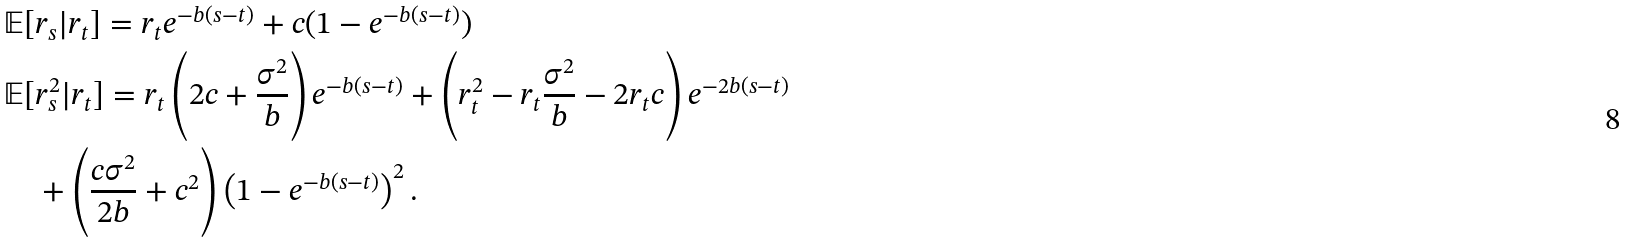Convert formula to latex. <formula><loc_0><loc_0><loc_500><loc_500>& \mathbb { E } [ r _ { s } | r _ { t } ] = r _ { t } e ^ { - b ( s - t ) } + c ( 1 - e ^ { - b ( s - t ) } ) \\ & \mathbb { E } [ r _ { s } ^ { 2 } | r _ { t } ] = r _ { t } \left ( 2 c + \frac { \sigma ^ { 2 } } { b } \right ) e ^ { - b ( s - t ) } + \left ( r _ { t } ^ { 2 } - r _ { t } \frac { \sigma ^ { 2 } } { b } - 2 r _ { t } c \right ) e ^ { - 2 b ( s - t ) } \\ & \quad + \left ( \frac { c \sigma ^ { 2 } } { 2 b } + c ^ { 2 } \right ) \left ( 1 - e ^ { - b ( s - t ) } \right ) ^ { 2 } .</formula> 